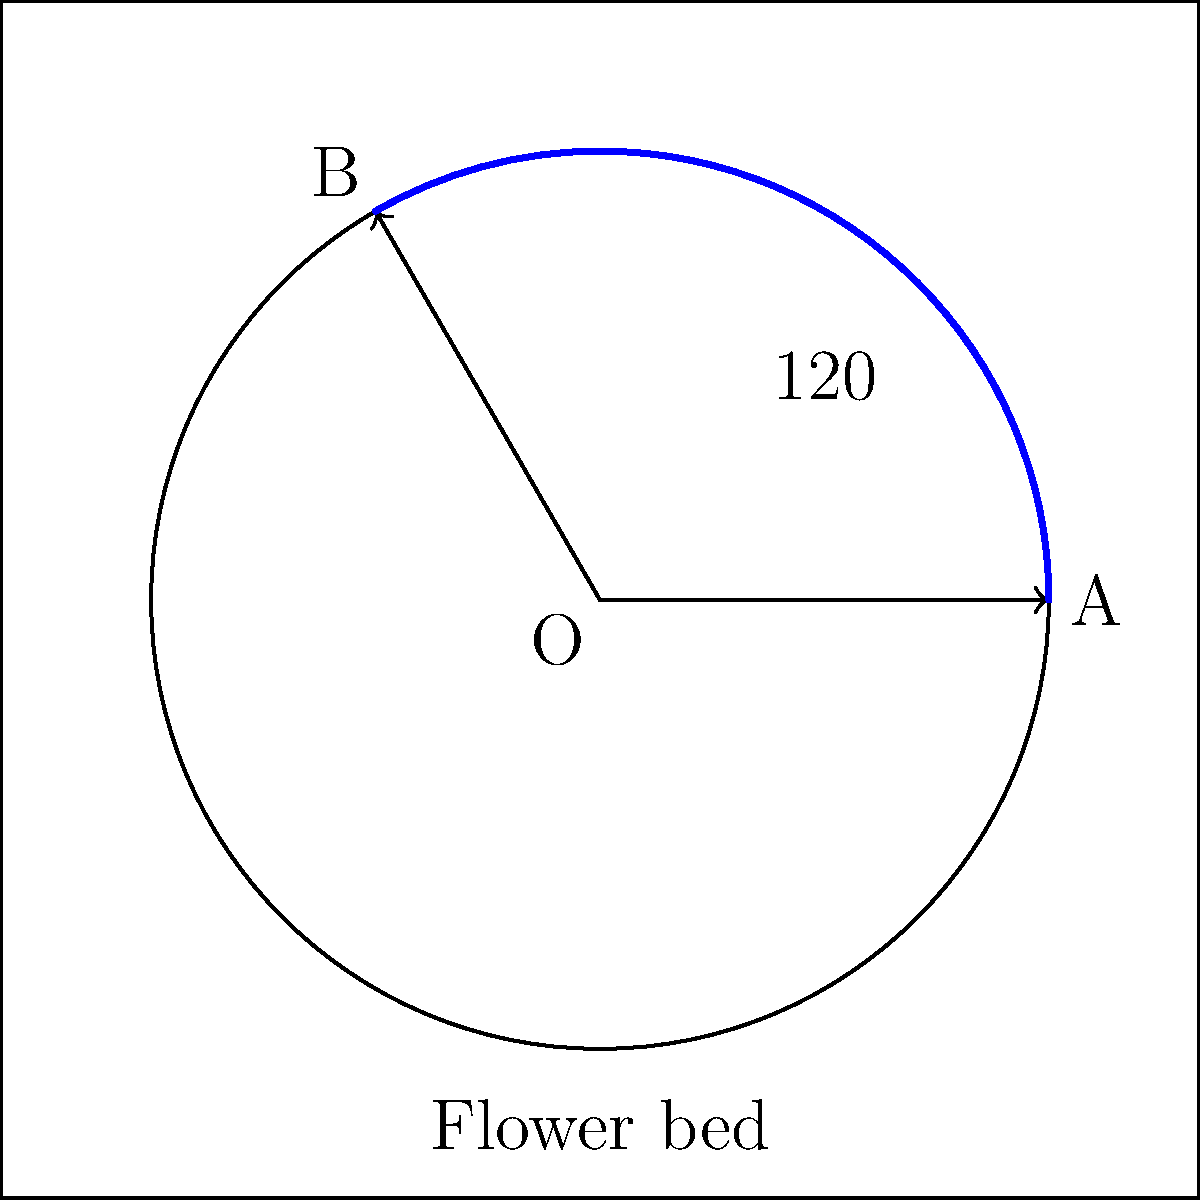You're designing a circular sprinkler system for a square flower bed in your garden. The sprinkler rotates from point A to point B, covering an angle of 120°. If the radius of the sprinkler's reach is 3 meters, what is the area of the flower bed that gets watered, rounded to the nearest square meter? To solve this problem, we'll follow these steps:

1) The area covered by the sprinkler is a sector of a circle. The formula for the area of a sector is:

   $A = \frac{\theta}{360°} \pi r^2$

   Where $\theta$ is the central angle in degrees, and $r$ is the radius.

2) We're given:
   $\theta = 120°$
   $r = 3$ meters

3) Let's substitute these values into our formula:

   $A = \frac{120°}{360°} \pi (3\text{ m})^2$

4) Simplify:
   $A = \frac{1}{3} \pi (9\text{ m}^2)$
   $A = 3\pi\text{ m}^2$

5) Calculate:
   $A \approx 3 \times 3.14159 \text{ m}^2 = 9.42477\text{ m}^2$

6) Rounding to the nearest square meter:
   $A \approx 9\text{ m}^2$

Therefore, the sprinkler system waters approximately 9 square meters of the flower bed.
Answer: 9 m² 